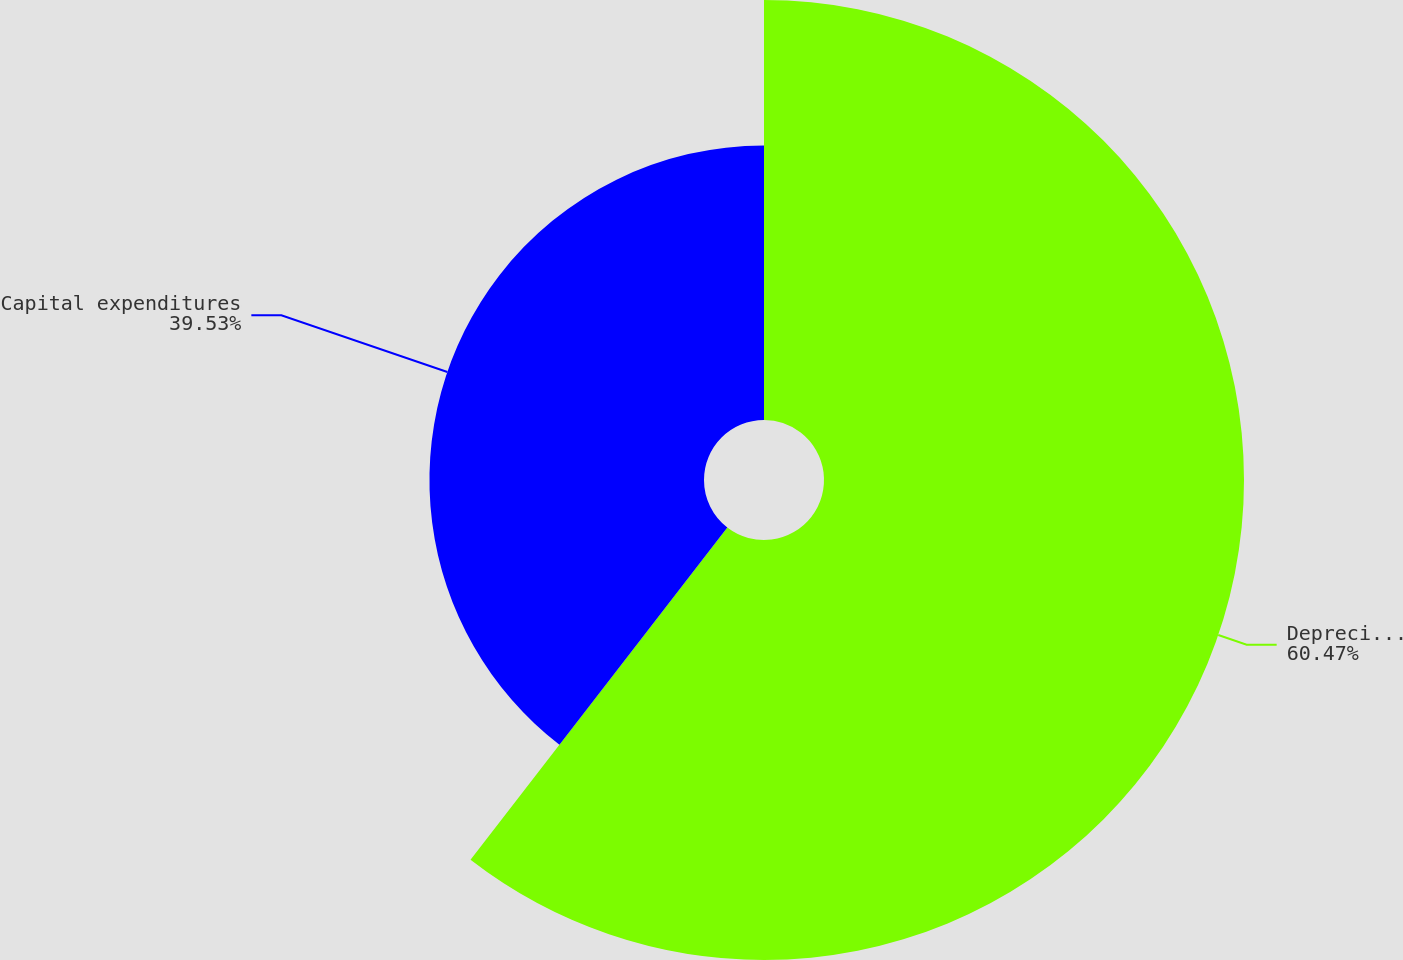Convert chart. <chart><loc_0><loc_0><loc_500><loc_500><pie_chart><fcel>Depreciation depletion and<fcel>Capital expenditures<nl><fcel>60.47%<fcel>39.53%<nl></chart> 